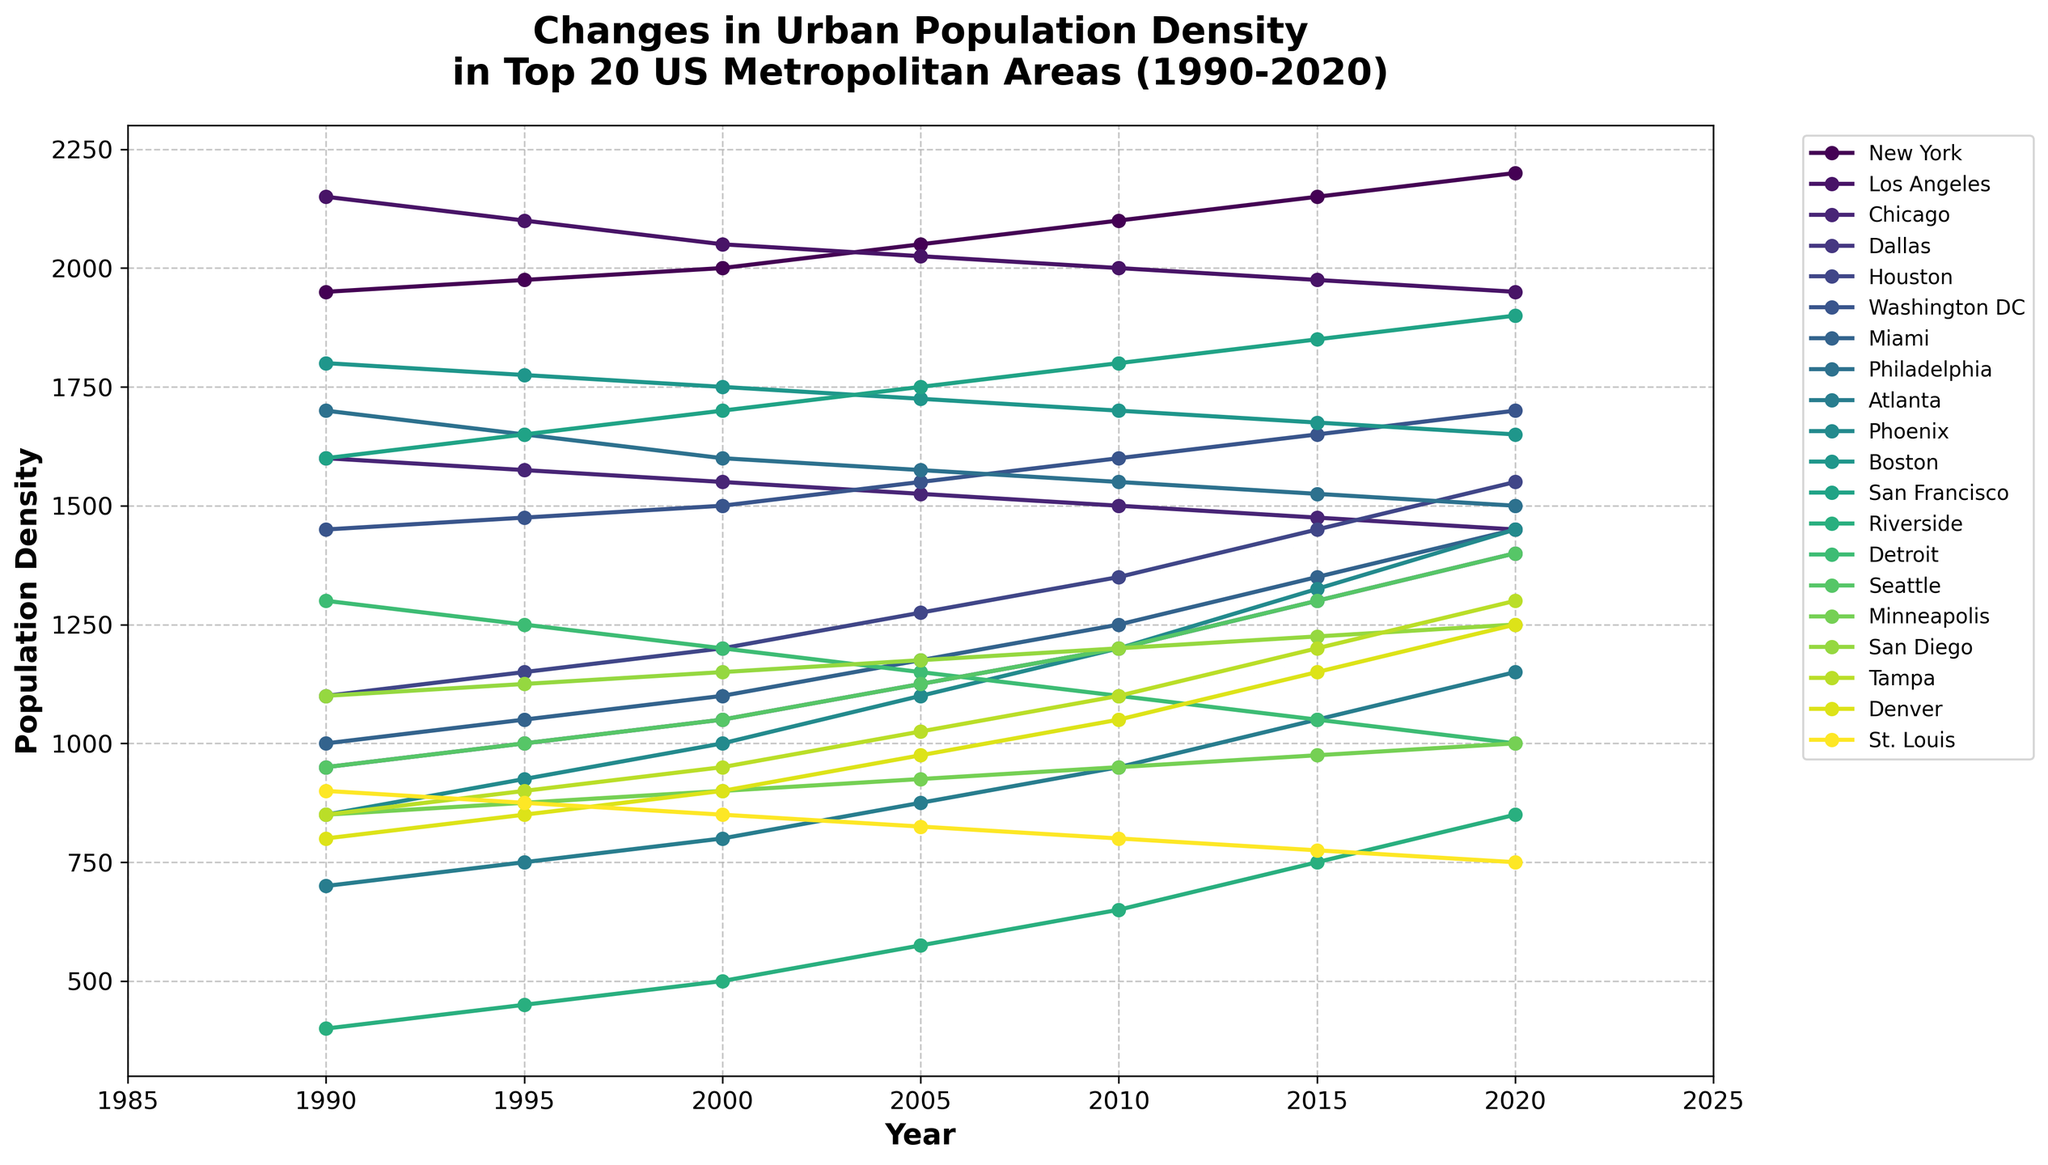Which metropolitan area had the highest population density in 2020? By examining the plotted lines for the year 2020, find the line with the highest point. New York's line reaches the highest value for that year.
Answer: New York How did the population density in Los Angeles change from 1990 to 2020? Look at the plotted line for Los Angeles and compare its values in 1990 and 2020. The density decreased from 2150 to 1950.
Answer: Decreased Which city showed the highest increase in population density from 1990 to 2020? Calculate the difference in density from 1990 to 2020 for each city and identify the city with the largest positive change. New York increased from 1950 to 2200, a change of 250.
Answer: New York Compare the population density trends of Chicago and Phoenix between 2000 and 2020. Which one increased more? Examine the plotted lines for Chicago and Phoenix between 2000 and 2020. Calculate the difference for each city: Chicago decreased from 1550 to 1450, while Phoenix increased from 1000 to 1450.
Answer: Phoenix Which city had the least population density in 2000? Compare the plotted points for all cities in the year 2000 and identify the lowest point. Riverside had a density of 500.
Answer: Riverside Observe the color trends. Which color represents San Francisco and what pattern does it show? By looking at the plotted line colors, identify the color corresponding to San Francisco and describe the pattern from 1990 to 2020. It’s a teal line showing a generally upward trend.
Answer: Teal, increasing What was the average population density of Dallas from 1990 to 2020? Calculate the average of Dallas’s population densities over the seven time points: (950 + 1000 + 1050 + 1125 + 1200 + 1300 + 1400) / 7 = 1146.43.
Answer: 1146.43 Over the last 30 years, did Washington DC's population density ever surpass Los Angeles? Examine the plotted lines for Washington DC and Los Angeles to check if Washington DC is ever above Los Angeles. It did not.
Answer: No Compare the population density of Tampa and Denver in 2015. Which city had the higher density? Look at the plotted points for Tampa and Denver in 2015 and compare their values. Tampa had a density of 1200, while Denver had 1150.
Answer: Tampa Identify any three cities that showed an overall decreasing trend in population density from 1990 to 2020. By examining each city's plotted line from 1990 to 2020, identify those consistently trending downwards. Cities like Detroit, Chicago, and St. Louis showed overall decreases.
Answer: Detroit, Chicago, St. Louis 